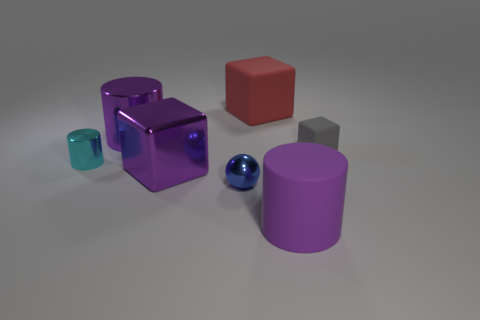Does the metallic cube have the same color as the matte cylinder?
Ensure brevity in your answer.  Yes. What is the size of the block that is the same color as the large matte cylinder?
Your response must be concise. Large. There is a small cyan object that is the same shape as the purple matte object; what is it made of?
Your answer should be very brief. Metal. There is a large cylinder that is in front of the tiny block; is its color the same as the small block?
Ensure brevity in your answer.  No. Is the blue ball made of the same material as the object in front of the blue shiny object?
Provide a succinct answer. No. There is a big thing that is right of the red rubber object; what shape is it?
Ensure brevity in your answer.  Cylinder. How many other objects are the same material as the tiny cylinder?
Ensure brevity in your answer.  3. The gray rubber thing is what size?
Ensure brevity in your answer.  Small. How many other things are there of the same color as the sphere?
Offer a terse response. 0. The small thing that is both to the right of the small cyan thing and behind the tiny blue metal thing is what color?
Make the answer very short. Gray. 